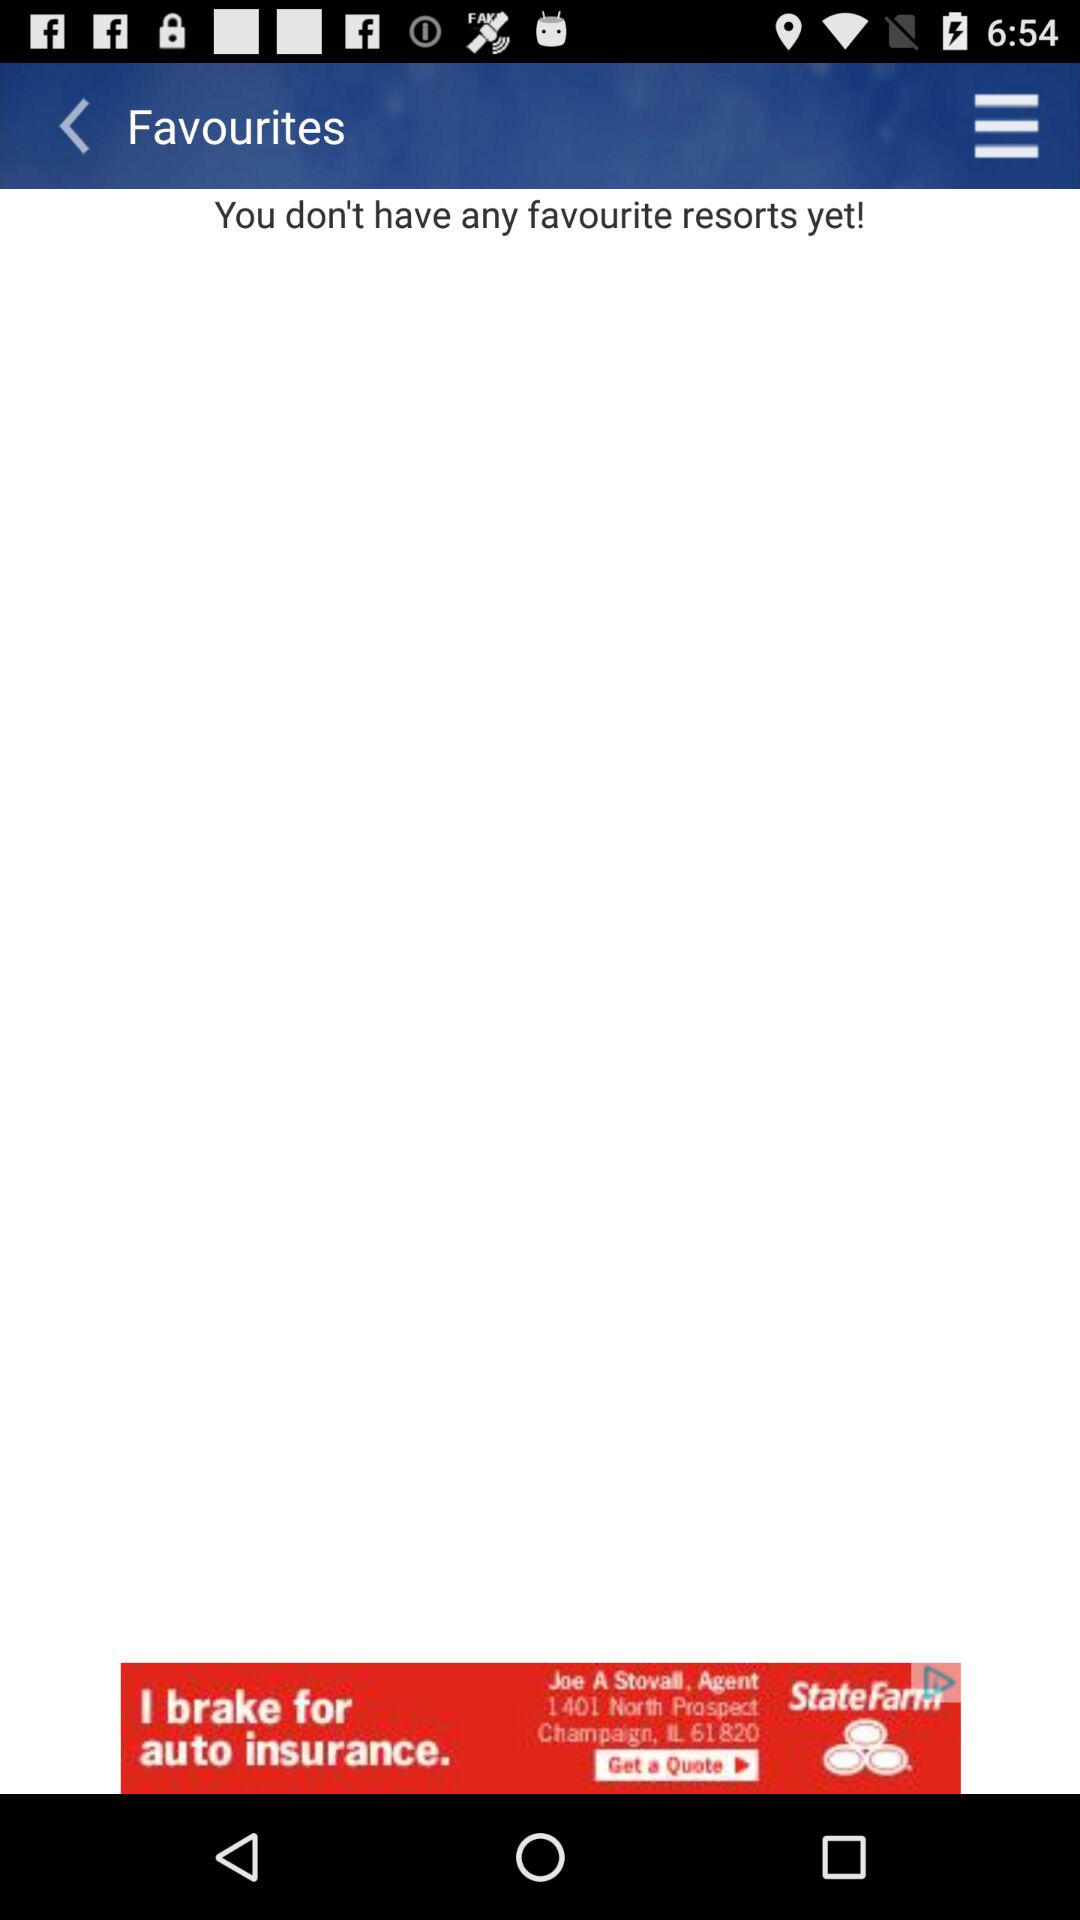How many resorts do I have on my favourite list? You don't have any resorts on your favourite list. 